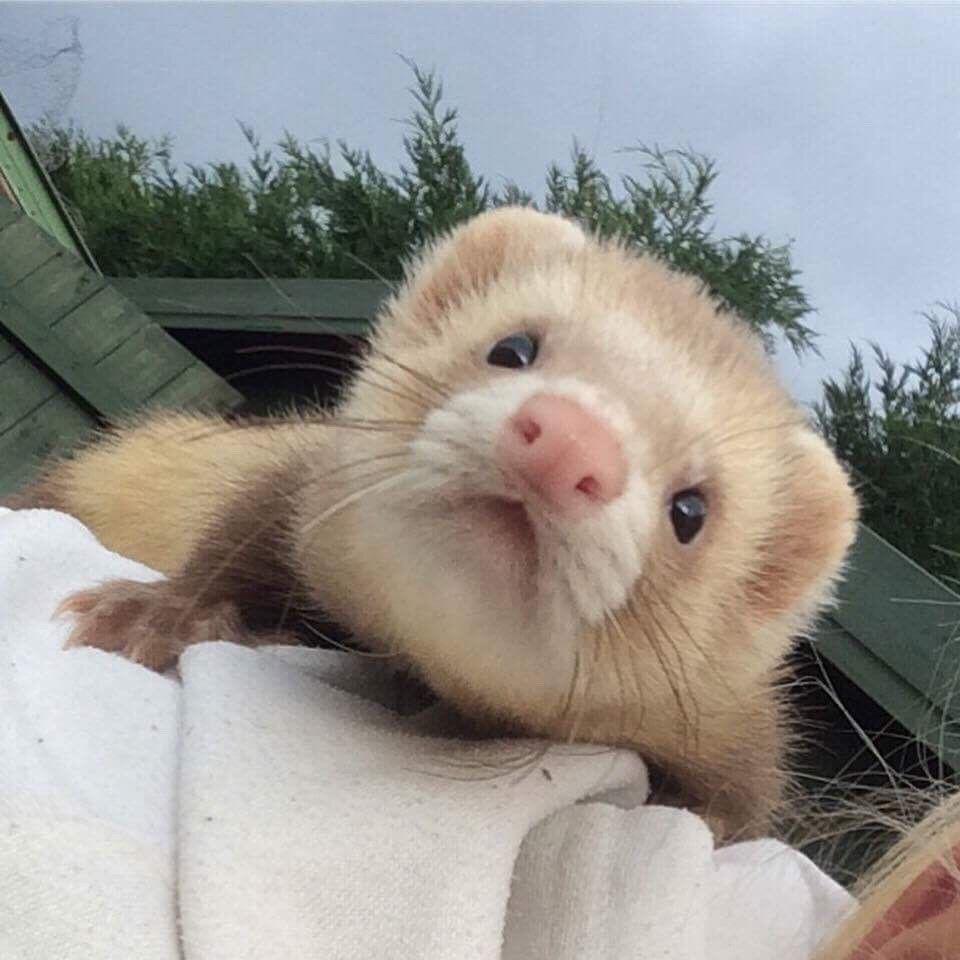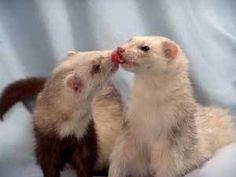The first image is the image on the left, the second image is the image on the right. Given the left and right images, does the statement "a pair of ferrets are next to each other on top of draped fabric" hold true? Answer yes or no. Yes. The first image is the image on the left, the second image is the image on the right. Assess this claim about the two images: "At least one guinea pig is cleaning another's face.". Correct or not? Answer yes or no. Yes. 